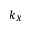Convert formula to latex. <formula><loc_0><loc_0><loc_500><loc_500>k _ { X }</formula> 